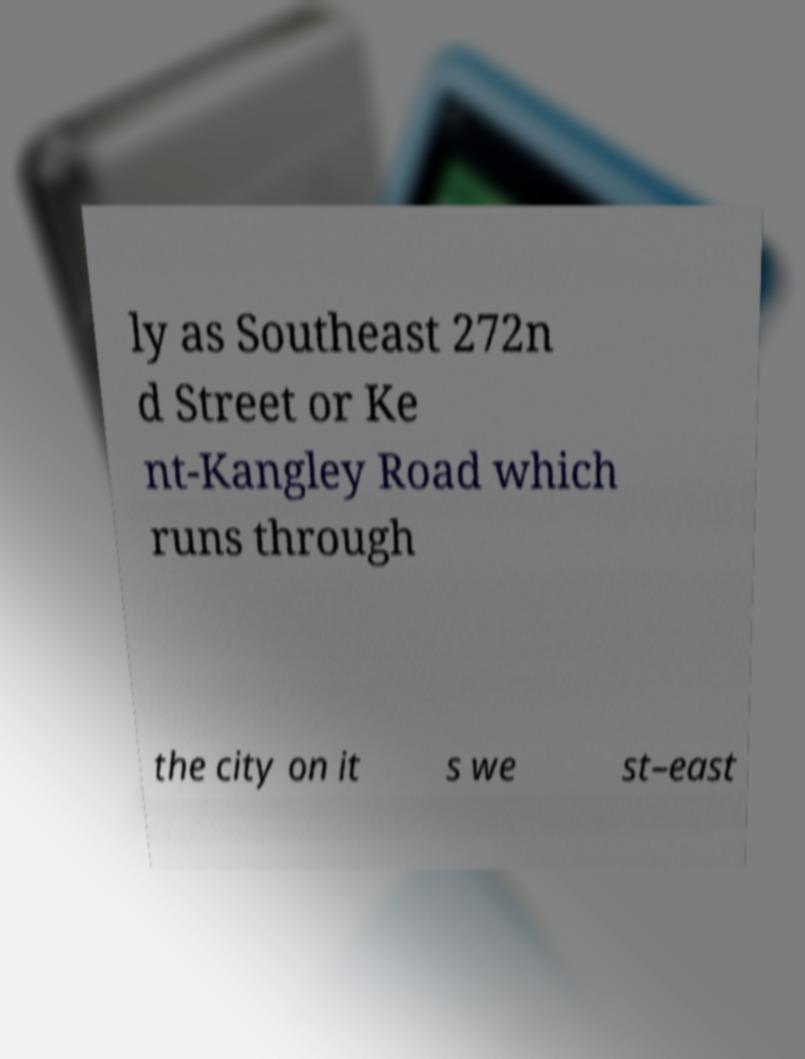There's text embedded in this image that I need extracted. Can you transcribe it verbatim? ly as Southeast 272n d Street or Ke nt-Kangley Road which runs through the city on it s we st–east 